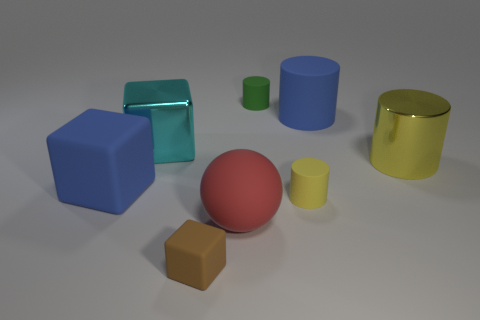There is a blue rubber thing that is to the right of the small thing that is in front of the yellow thing to the left of the blue cylinder; how big is it?
Give a very brief answer. Large. Are there any things that have the same color as the big shiny cylinder?
Make the answer very short. Yes. What number of cyan metallic blocks are there?
Keep it short and to the point. 1. There is a large cylinder that is in front of the metal thing behind the large metal object on the right side of the tiny green matte thing; what is it made of?
Keep it short and to the point. Metal. Is there a big purple cube made of the same material as the cyan thing?
Make the answer very short. No. Is the tiny yellow object made of the same material as the large cyan object?
Give a very brief answer. No. What number of cubes are yellow rubber things or large cyan metallic things?
Provide a succinct answer. 1. The tiny block that is the same material as the big red thing is what color?
Offer a very short reply. Brown. Are there fewer green matte cylinders than blue balls?
Offer a terse response. No. Do the big blue thing that is on the right side of the large blue block and the small rubber thing that is right of the green cylinder have the same shape?
Provide a short and direct response. Yes. 